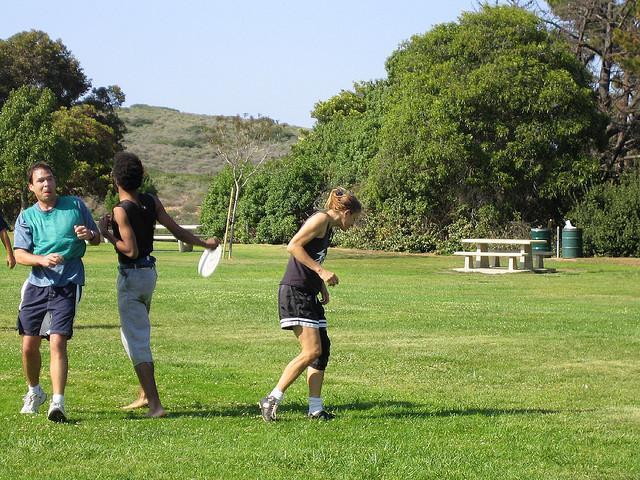How many people are wearing green shirts?
Give a very brief answer. 1. How many people are there?
Give a very brief answer. 3. How many zebras are facing the camera?
Give a very brief answer. 0. 